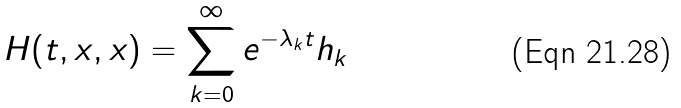<formula> <loc_0><loc_0><loc_500><loc_500>H ( t , x , x ) = \sum _ { k = 0 } ^ { \infty } e ^ { - \lambda _ { k } t } h _ { k }</formula> 